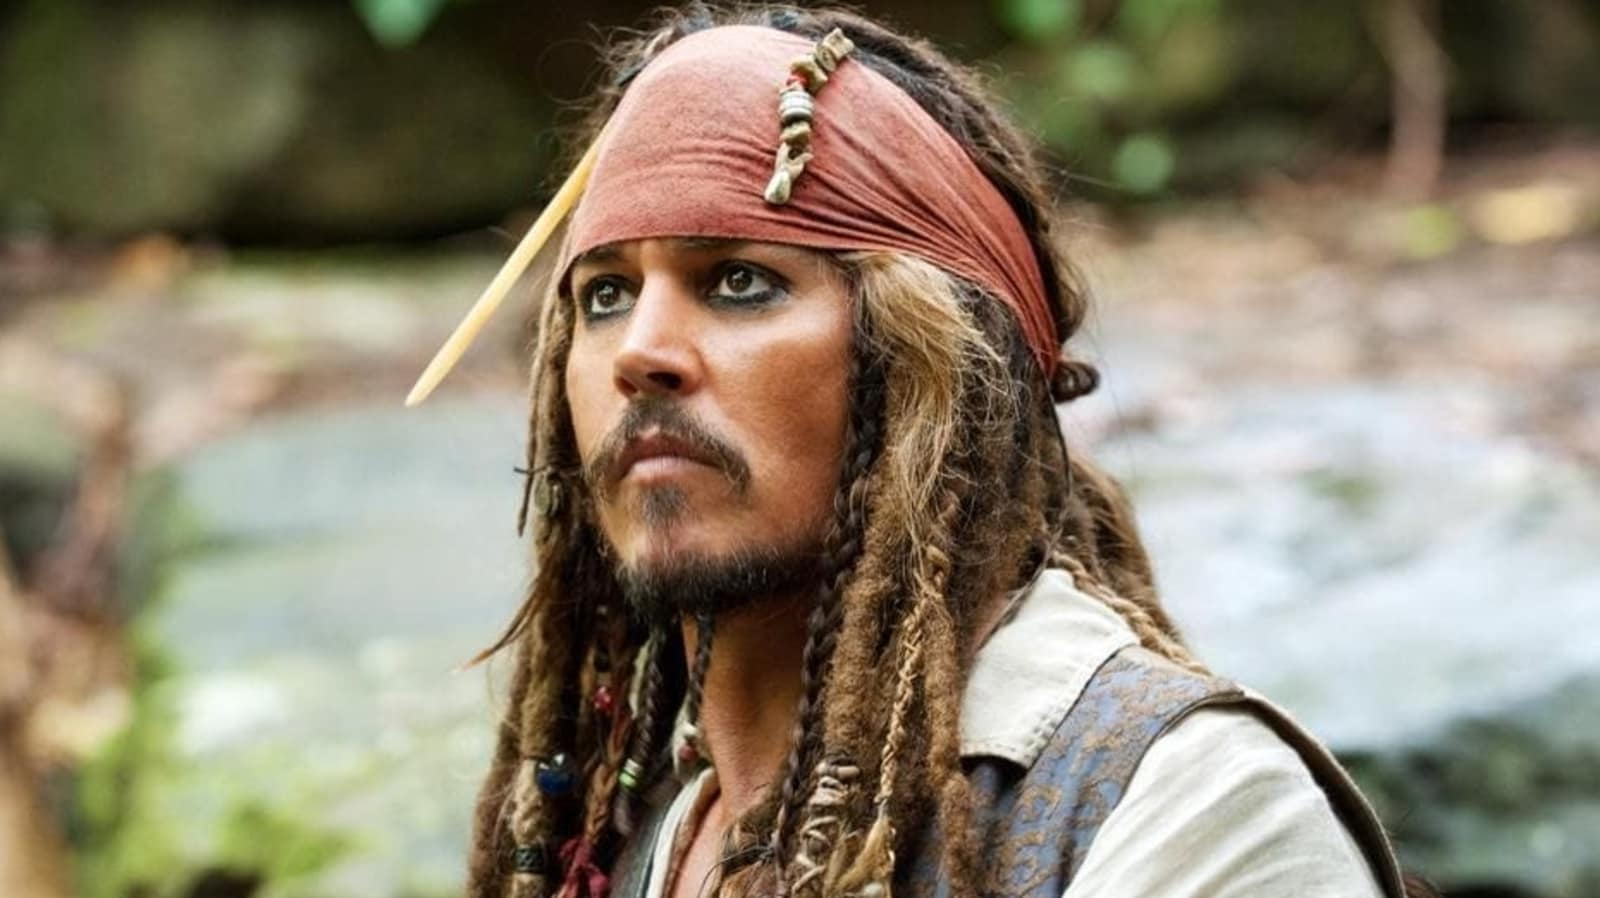What could be the significance of the forest and stream in the background? The forest and stream in the background add a significant amount of depth to the image. They provide a stark contrast to the character's rugged pirate persona, highlighting a more peaceful and natural setting. This juxtaposition could imply a moment of respite for the character, offering a calm before the storm of his next adventure. The serene environment could also symbolize a sanctuary or a place where the character finds solace and plans his next move. Can you narrate a brief story that could be happening in this setting? In a quiet forest glade, Captain Jack Sparrow finds himself standing by a gently flowing stream. The sound of the water provides a soothing backdrop as he studies an ancient, weathered map. The treasure it points to is rumored to lie deep within these woods, guarded by time and nature. As dusk falls, casting long shadows across the scene, Jack readies himself for the journey ahead, knowing that once he ventures beyond this peaceful stream, he will face untold dangers and challenges. But for now, he takes a moment to enjoy the tranquility, steeling himself for the adventure that beckons. 